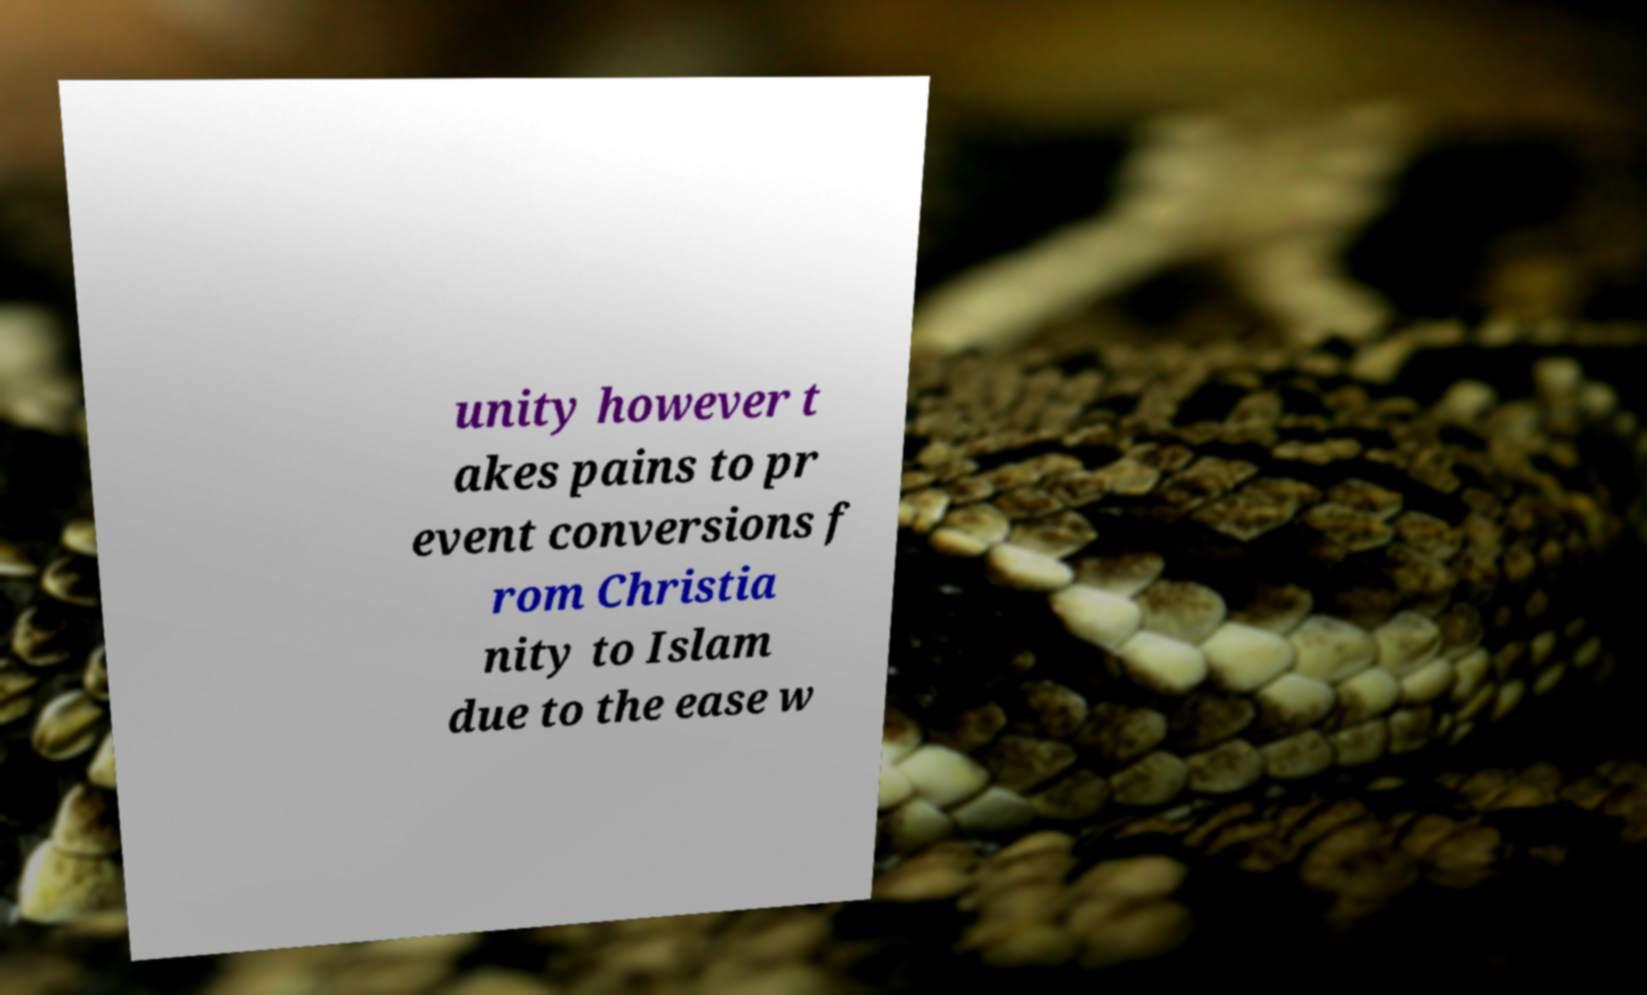Could you extract and type out the text from this image? unity however t akes pains to pr event conversions f rom Christia nity to Islam due to the ease w 